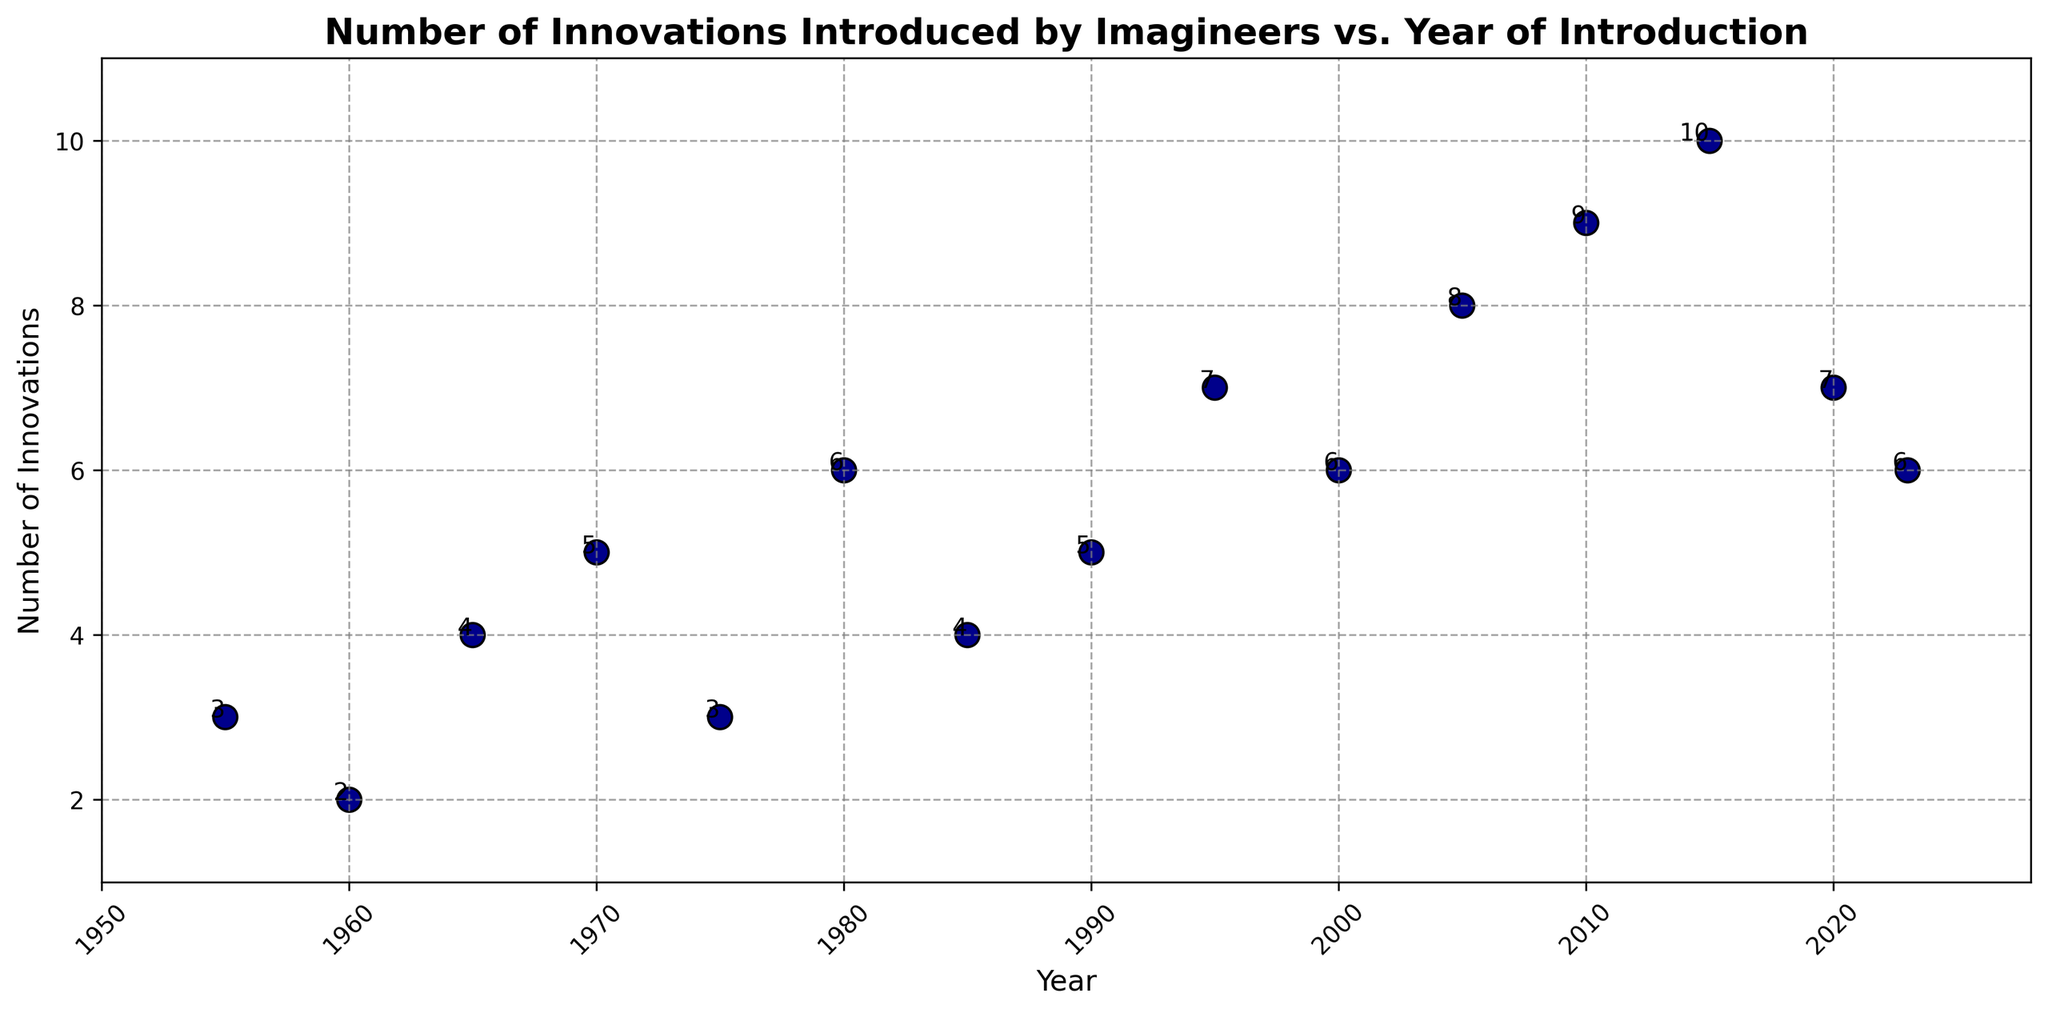What was the highest number of innovations introduced in a single year? To find the highest number of innovations, look at the scatter plot and identify the maximum value on the y-axis. The highest y-value corresponds to the highest number of innovations.
Answer: 10 Between which years did the number of innovations increase the most? Observe the years and corresponding y-axis values to see where the greatest upward change occurs. The largest increase in innovations happened between the year 2010 (9 innovations) and the year 2015 (10 innovations).
Answer: 2010 and 2015 Which year had the least number of innovations introduced? Find the data point with the lowest value on the y-axis. The year with the lowest number of innovations introduced is 1960 with 2 innovations.
Answer: 1960 How many years had more than 5 innovations introduced? Count the number of data points where the y-value is greater than 5. Years with more than 5 innovations include 1980 (6), 1995 (7), 2000 (6), 2005 (8), 2010 (9), 2015 (10), and 2020 (7). There are 6 such years.
Answer: 6 What was the total number of innovations introduced between 1955 and 1970? Sum the innovations for the years 1955, 1960, 1965, and 1970. The calculation is 3 (1955) + 2 (1960) + 4 (1965) + 5 (1970) = 14.
Answer: 14 Is there a trend in the number of innovations introduced over time? Analyze the scatter plot to identify a trend. Visually, there appears to be a general upward trend in the number of innovations introduced over time.
Answer: Upward trend Which year had an equal number of innovations as in 1985? To find a year with the same number of innovations as in 1985 (4 innovations), look for other points with a y-value of 4. Another data point with 4 innovations is 1965.
Answer: 1965 What’s the average number of innovations introduced per year over the whole period? To find the average, sum all the innovations and divide by the number of years. The sum is 3+2+4+5+3+6+4+5+7+6+8+9+10+7+6 = 85. The number of years is 15. The average is 85/15 = 5.67.
Answer: 5.67 What is the median number of innovations introduced? To find the median, first order the number of innovations: 2, 3, 3, 4, 4, 5, 5, 6, 6, 6, 7, 7, 8, 9, 10. The median is the middle value, which is the 8th value in this sequence, thus the median is 6.
Answer: 6 